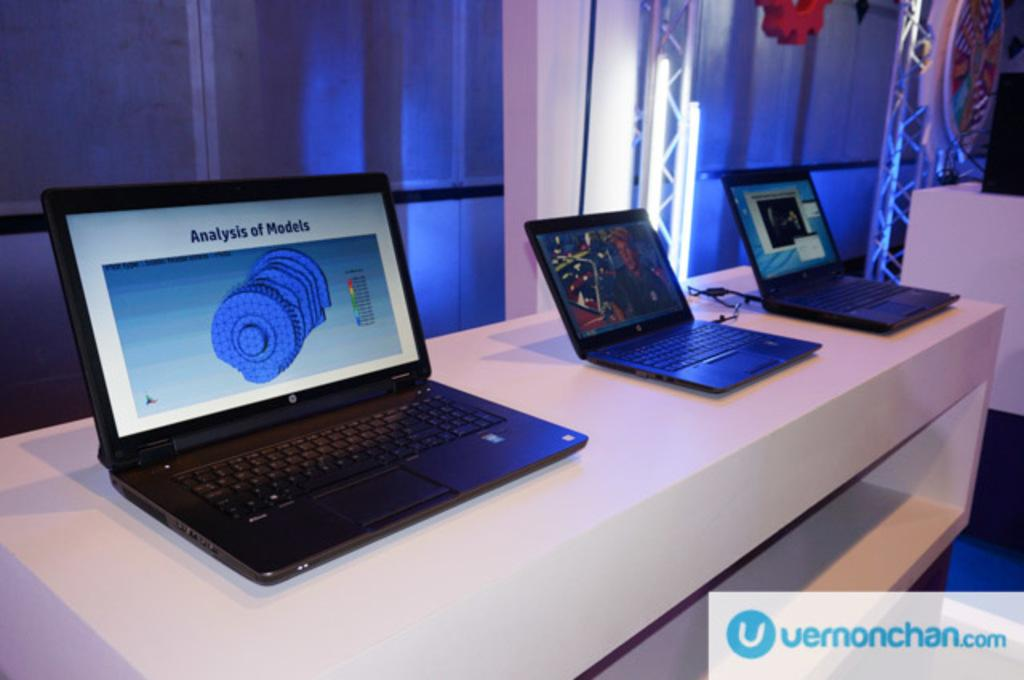<image>
Provide a brief description of the given image. A laptop is open, next to two others, to a screen that shows an analysis of models. 